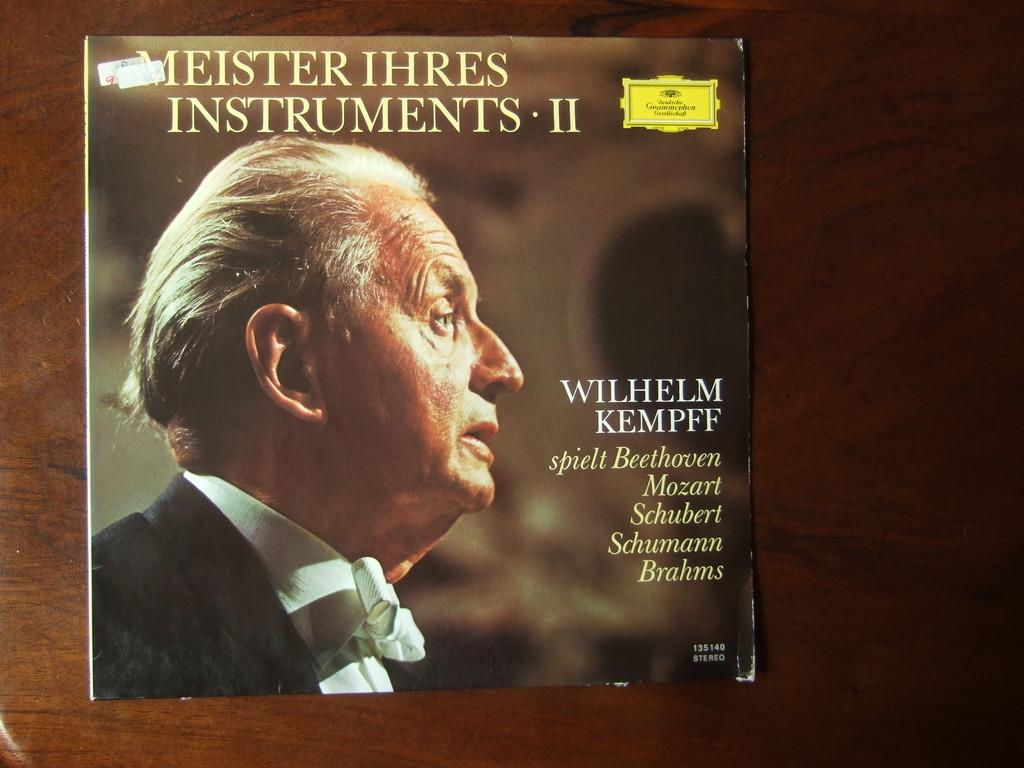Who is present in the image? There is a man in the image. What can be seen that is written in the image? There is something written in the image. What type of object can be seen in the background of the image? There is a wooden object in the background of the image. What type of lock is used to secure the company's assets in the image? There is no mention of a company or any assets in the image, nor is there a lock present. 